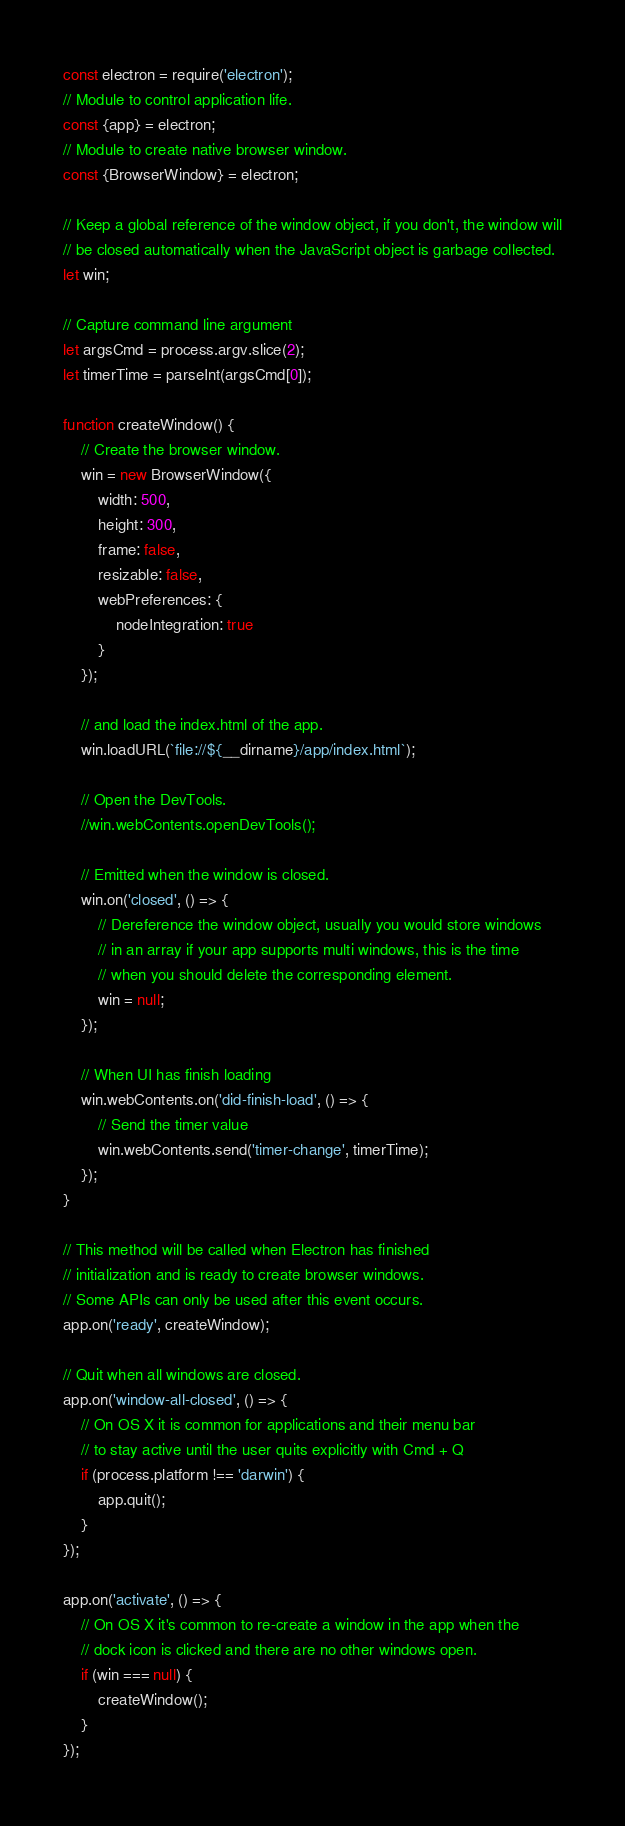Convert code to text. <code><loc_0><loc_0><loc_500><loc_500><_JavaScript_>const electron = require('electron');
// Module to control application life.
const {app} = electron;
// Module to create native browser window.
const {BrowserWindow} = electron;

// Keep a global reference of the window object, if you don't, the window will
// be closed automatically when the JavaScript object is garbage collected.
let win;

// Capture command line argument
let argsCmd = process.argv.slice(2);
let timerTime = parseInt(argsCmd[0]);

function createWindow() {
    // Create the browser window.
    win = new BrowserWindow({
        width: 500,
        height: 300,
        frame: false,
        resizable: false,
        webPreferences: {
            nodeIntegration: true
        }
    });

    // and load the index.html of the app.
    win.loadURL(`file://${__dirname}/app/index.html`);

    // Open the DevTools.
    //win.webContents.openDevTools();

    // Emitted when the window is closed.
    win.on('closed', () => {
        // Dereference the window object, usually you would store windows
        // in an array if your app supports multi windows, this is the time
        // when you should delete the corresponding element.
        win = null;
    });

    // When UI has finish loading
    win.webContents.on('did-finish-load', () => {
        // Send the timer value
        win.webContents.send('timer-change', timerTime);
    });
}

// This method will be called when Electron has finished
// initialization and is ready to create browser windows.
// Some APIs can only be used after this event occurs.
app.on('ready', createWindow);

// Quit when all windows are closed.
app.on('window-all-closed', () => {
    // On OS X it is common for applications and their menu bar
    // to stay active until the user quits explicitly with Cmd + Q
    if (process.platform !== 'darwin') {
        app.quit();
    }
});

app.on('activate', () => {
    // On OS X it's common to re-create a window in the app when the
    // dock icon is clicked and there are no other windows open.
    if (win === null) {
        createWindow();
    }
});</code> 